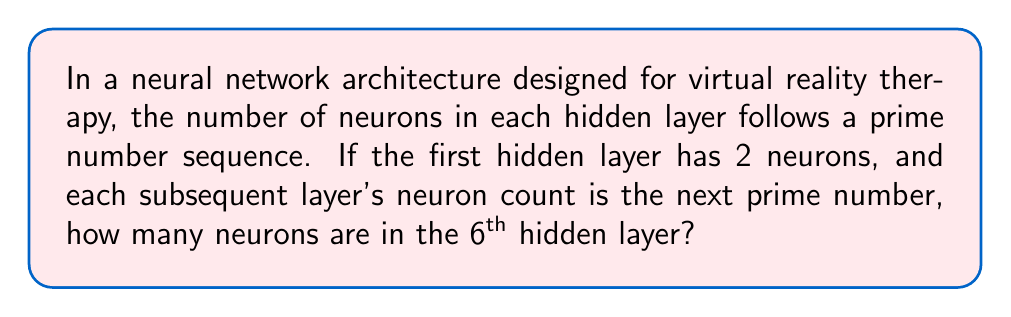Can you solve this math problem? To solve this problem, we need to follow these steps:

1. Identify the prime number sequence starting from 2:
   The sequence begins: 2, 3, 5, 7, 11, 13, ...

2. Map the hidden layers to this sequence:
   - 1st hidden layer: 2 neurons
   - 2nd hidden layer: 3 neurons
   - 3rd hidden layer: 5 neurons
   - 4th hidden layer: 7 neurons
   - 5th hidden layer: 11 neurons
   - 6th hidden layer: 13 neurons

3. The question asks for the number of neurons in the 6th hidden layer, which corresponds to the 6th prime number in the sequence.

This problem relates to the given persona by incorporating neural network architectures used in virtual reality therapy, while also addressing the topic of prime number distribution patterns in these architectures.
Answer: 13 